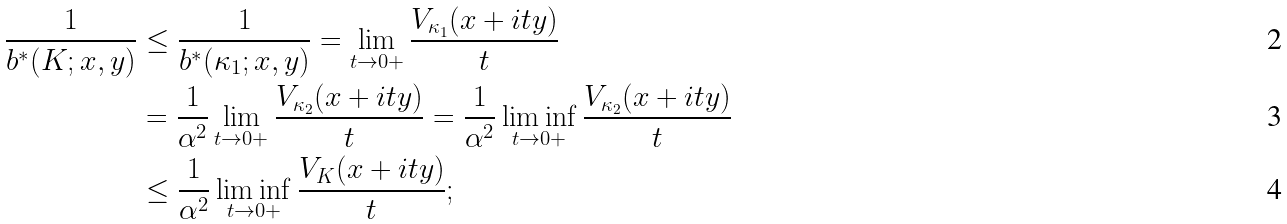<formula> <loc_0><loc_0><loc_500><loc_500>\frac { 1 } { b ^ { * } ( K ; x , y ) } & \leq \frac { 1 } { b ^ { * } ( \kappa _ { 1 } ; x , y ) } = \lim _ { t \to 0 + } \frac { V _ { \kappa _ { 1 } } ( x + i t y ) } { t } \\ & = \frac { 1 } { \alpha ^ { 2 } } \lim _ { t \to 0 + } \frac { V _ { \kappa _ { 2 } } ( x + i t y ) } { t } = \frac { 1 } { \alpha ^ { 2 } } \liminf _ { t \to 0 + } \frac { V _ { \kappa _ { 2 } } ( x + i t y ) } { t } \\ & \leq \frac { 1 } { \alpha ^ { 2 } } \liminf _ { t \to 0 + } \frac { V _ { K } ( x + i t y ) } { t } ;</formula> 